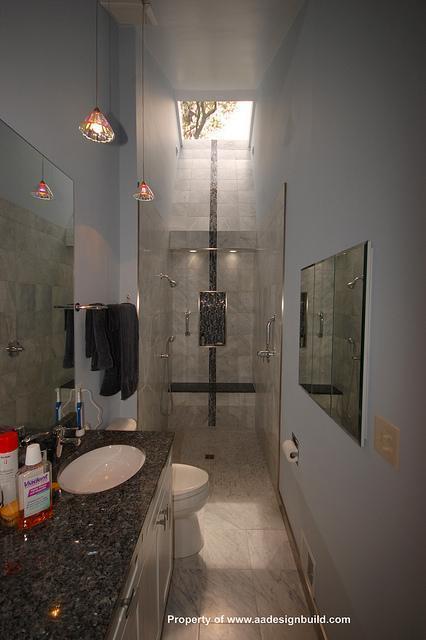What is the item with the white cap used to clean?
Choose the correct response and explain in the format: 'Answer: answer
Rationale: rationale.'
Options: Mouth, shoes, clothes, dog hair. Answer: mouth.
Rationale: That item often has as a bright colour and a long white cap. What color is the fluid in the small container with the white cap on the top?
Select the correct answer and articulate reasoning with the following format: 'Answer: answer
Rationale: rationale.'
Options: Purple, red, blue, green. Answer: red.
Rationale: Mouthwash often comes in these colours. 